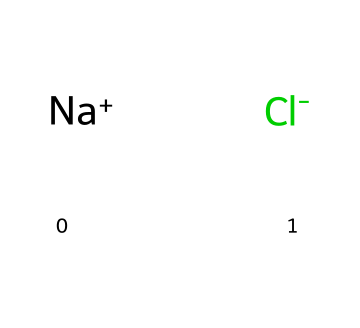What is the name of this chemical? The chemical composition represented by the SMILES notation [Na+].[Cl-] corresponds to sodium chloride, commonly known as table salt or road salt.
Answer: sodium chloride How many atoms are in this chemical? The SMILES representation shows sodium (Na) and chlorine (Cl), which indicates there are two atoms — one sodium atom and one chlorine atom.
Answer: two What type of chemical bond is present in this compound? The structure indicates an ionic bond, as sodium (Na) donates an electron to chlorine (Cl), resulting in a positively charged sodium ion and a negatively charged chloride ion that attract each other.
Answer: ionic bond What is the charge of the sodium ion? The notation [Na+] indicates that the sodium ion carries a positive charge.
Answer: positive What is the primary use of this chemical in Maine during winter? Sodium chloride is primarily used for de-icing roads during winter, as it lowers the freezing point of water, preventing ice formation.
Answer: de-icing Which element is responsible for the salinity of this compound? The chlorine atom (Cl), which is an anion in this compound, is primarily responsible for the salinity in sodium chloride, giving it its characteristic salty flavor.
Answer: chlorine What state of matter is sodium chloride usually found in at room temperature? At room temperature, sodium chloride is commonly found in solid state, forming a crystalline structure.
Answer: solid 